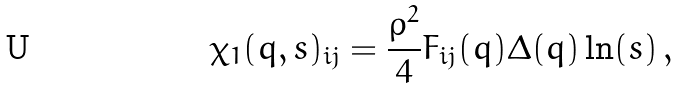Convert formula to latex. <formula><loc_0><loc_0><loc_500><loc_500>\chi _ { 1 } ( q , s ) _ { i j } = \frac { \rho ^ { 2 } } { 4 } F _ { i j } ( q ) \Delta ( q ) \ln ( s ) \, ,</formula> 